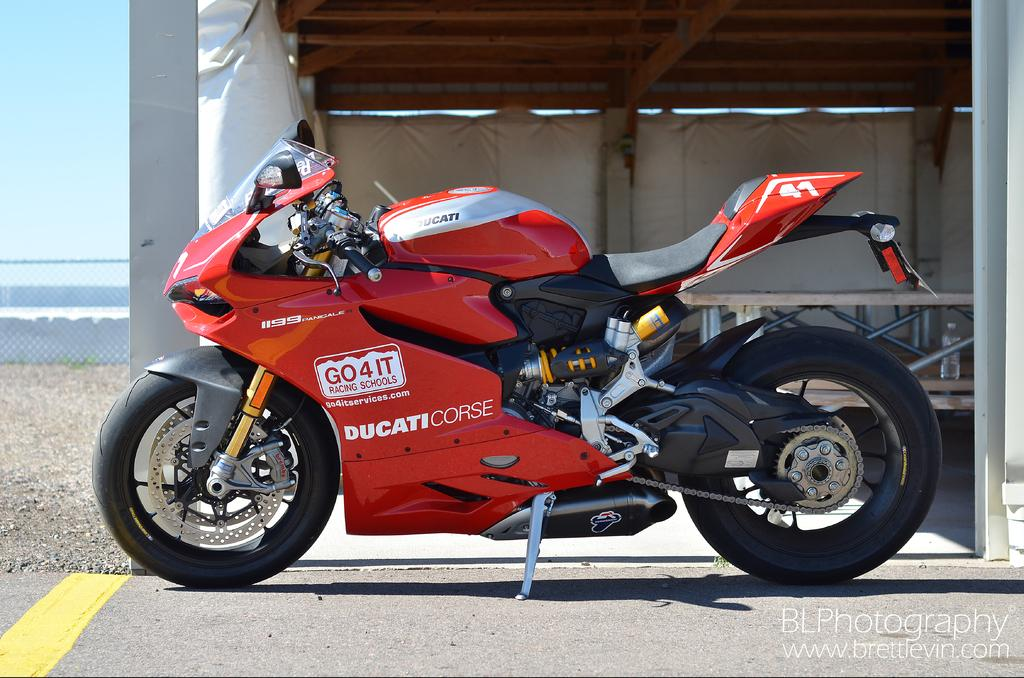<image>
Offer a succinct explanation of the picture presented. Ducaticorse red and black motorcycle parked on a highway 